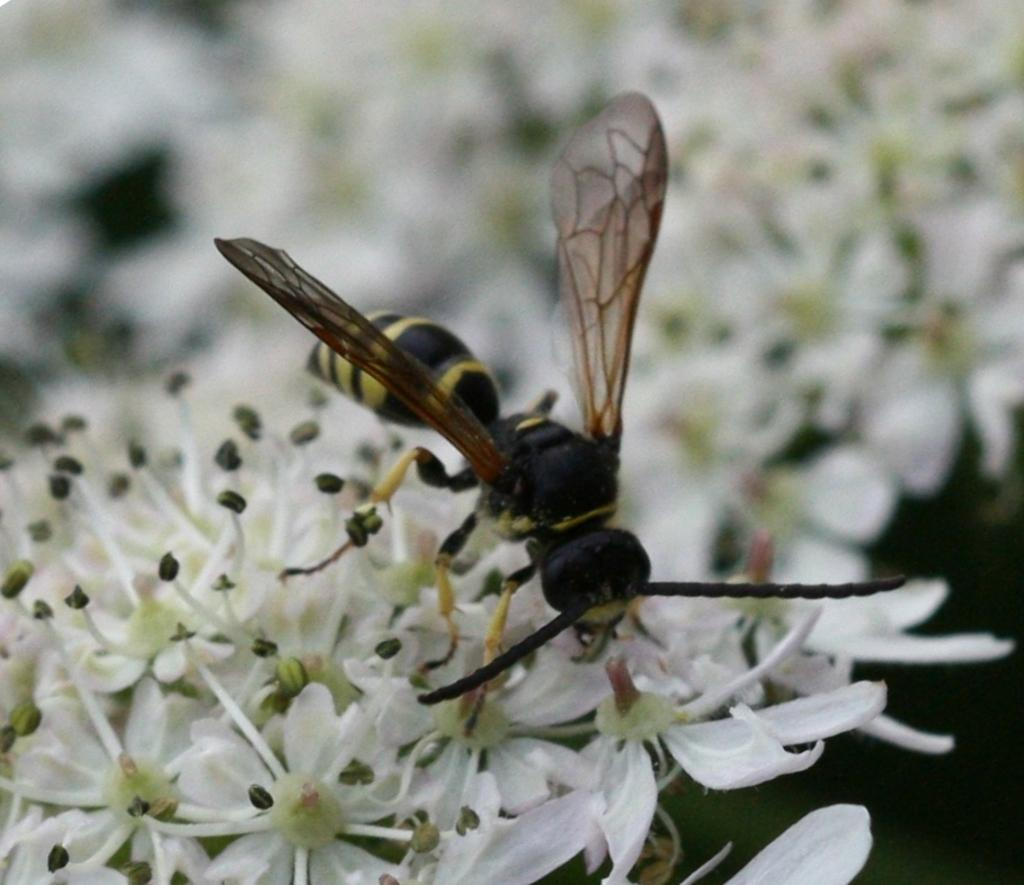What insect is present in the image? There is a dragonfly in the image. What colors can be seen on the dragonfly? The dragonfly is in black, brown, and yellow colors. What type of plants are in the image? There are flowers in the image. What colors are the flowers? The flowers are in white and green colors. Where is the dragonfly located in relation to the flowers? The dragonfly is on the flowers. What type of street is visible in the image? There is no street present in the image; it features a dragonfly on flowers. Is there a tent in the image? There is no tent present in the image; it features a dragonfly on flowers. 